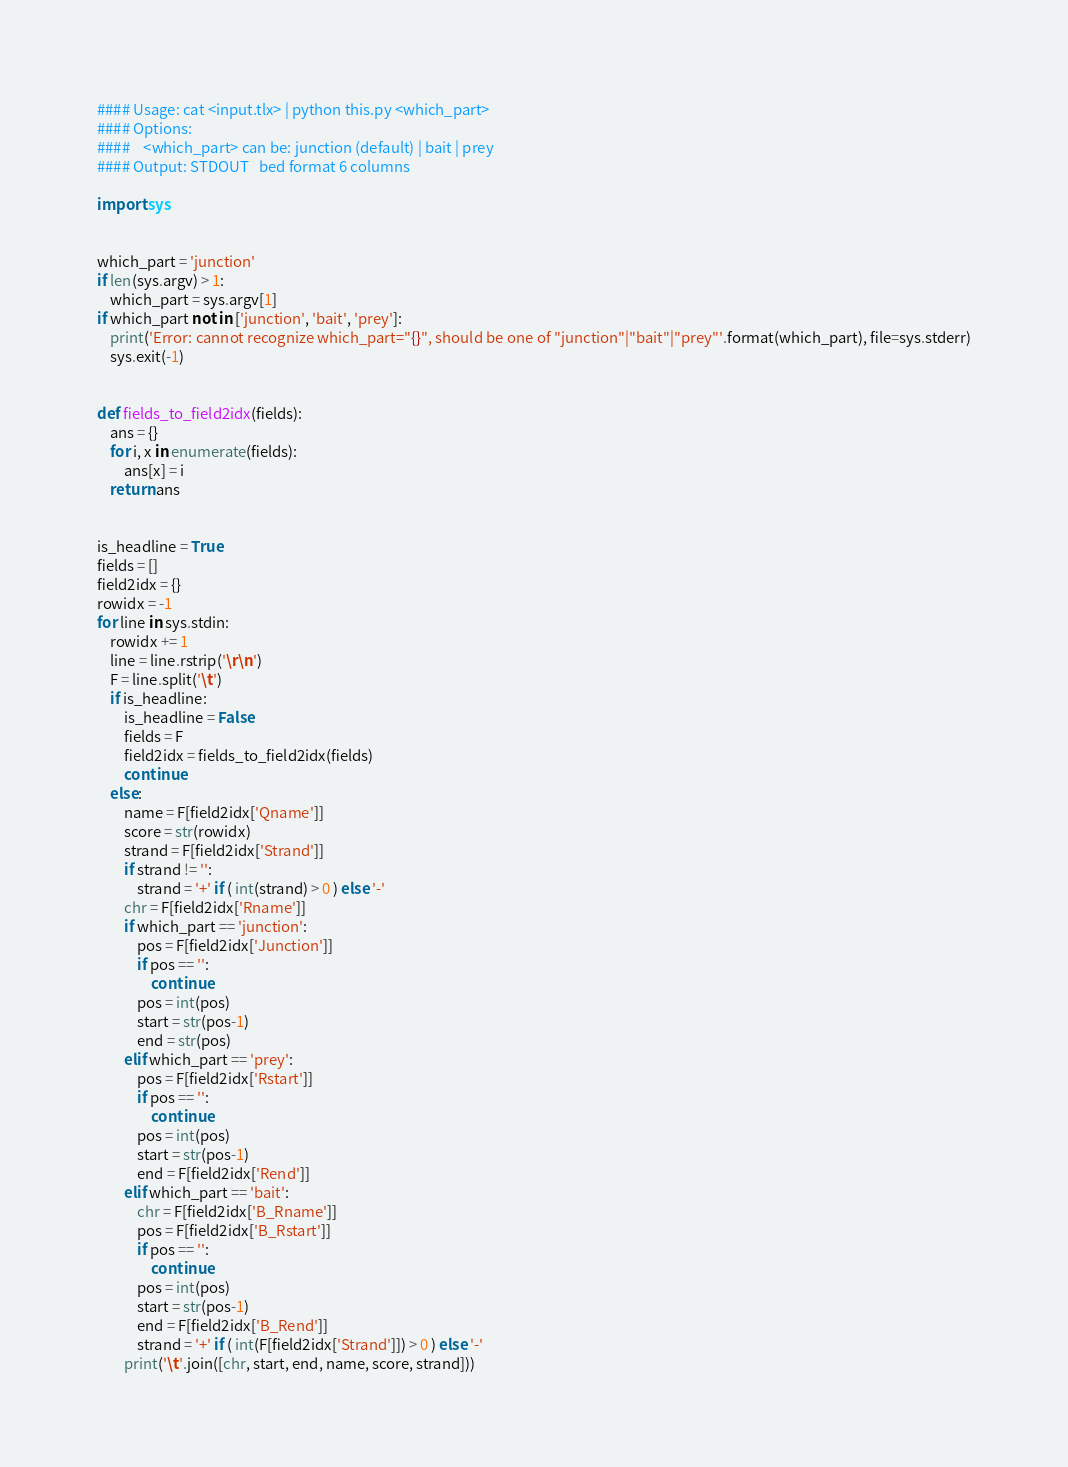Convert code to text. <code><loc_0><loc_0><loc_500><loc_500><_Python_>
#### Usage: cat <input.tlx> | python this.py <which_part>
#### Options:
####    <which_part> can be: junction (default) | bait | prey
#### Output: STDOUT   bed format 6 columns

import sys


which_part = 'junction'
if len(sys.argv) > 1:
	which_part = sys.argv[1]
if which_part not in ['junction', 'bait', 'prey']:
	print('Error: cannot recognize which_part="{}", should be one of "junction"|"bait"|"prey"'.format(which_part), file=sys.stderr)
	sys.exit(-1)


def fields_to_field2idx(fields):
	ans = {}
	for i, x in enumerate(fields):
		ans[x] = i
	return ans


is_headline = True
fields = []
field2idx = {}
rowidx = -1
for line in sys.stdin:
	rowidx += 1
	line = line.rstrip('\r\n')
	F = line.split('\t')
	if is_headline:
		is_headline = False
		fields = F
		field2idx = fields_to_field2idx(fields)
		continue
	else:
		name = F[field2idx['Qname']]
		score = str(rowidx)
		strand = F[field2idx['Strand']]
		if strand != '':
			strand = '+' if ( int(strand) > 0 ) else '-'
		chr = F[field2idx['Rname']]
		if which_part == 'junction':
			pos = F[field2idx['Junction']]
			if pos == '':
				continue
			pos = int(pos)
			start = str(pos-1)
			end = str(pos)
		elif which_part == 'prey':
			pos = F[field2idx['Rstart']]
			if pos == '':
				continue
			pos = int(pos)
			start = str(pos-1)
			end = F[field2idx['Rend']]
		elif which_part == 'bait':
			chr = F[field2idx['B_Rname']]
			pos = F[field2idx['B_Rstart']]
			if pos == '':
				continue
			pos = int(pos)
			start = str(pos-1)
			end = F[field2idx['B_Rend']]
			strand = '+' if ( int(F[field2idx['Strand']]) > 0 ) else '-'
		print('\t'.join([chr, start, end, name, score, strand]))
</code> 